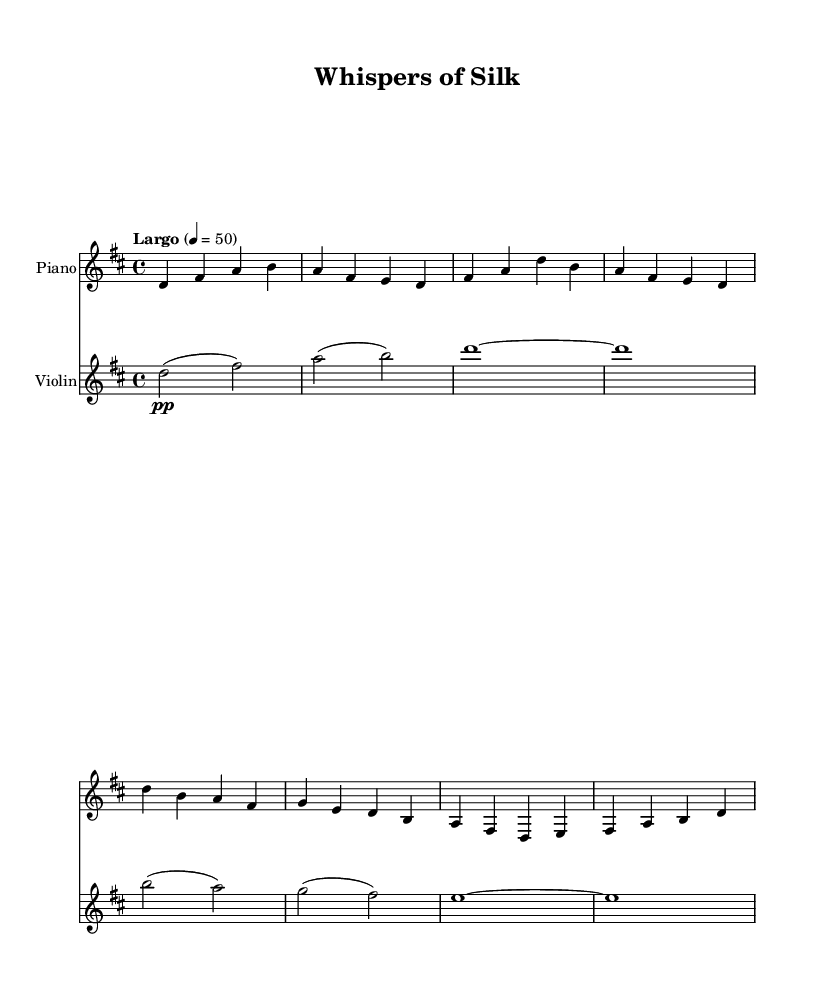What is the key signature of this music? The key signature is D major, which has two sharps indicated on the staff at the beginning.
Answer: D major What is the time signature of this music? The time signature is 4/4, which is indicated by the "4/4" mark at the beginning of the score.
Answer: 4/4 What is the tempo marking for this piece? The tempo marking indicates "Largo" with a metronome marking of quarter note equals 50, specifying a slow speed for the performance.
Answer: Largo, 4 = 50 How many measures are in the piano part? The piano part consists of 8 measures, which can be counted by looking at the bar lines within the written segment for the piano.
Answer: 8 measures What dynamic marking is found in the violin part for the first note? The first note of the violin part has a dynamic marking of "pp," which indicates that it should be played very softly.
Answer: pp Which instrument plays the melody in this piece? The melody is primarily played by the violin, as it has longer notes and a more prominent line compared to the accompanying piano.
Answer: Violin How many beats does the violin hold on the first note? In the violin part, the first note is held for 2 beats, as indicated by the "d2" note value.
Answer: 2 beats 